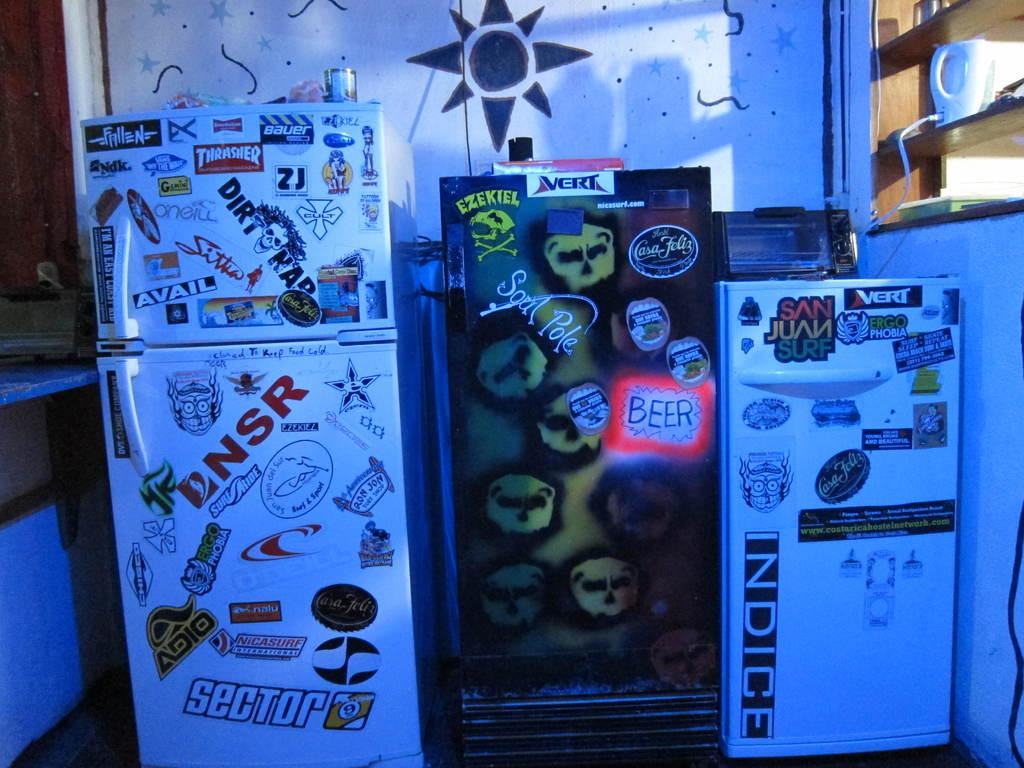Provide a one-sentence caption for the provided image. a fridge that has sector at the bottom. 